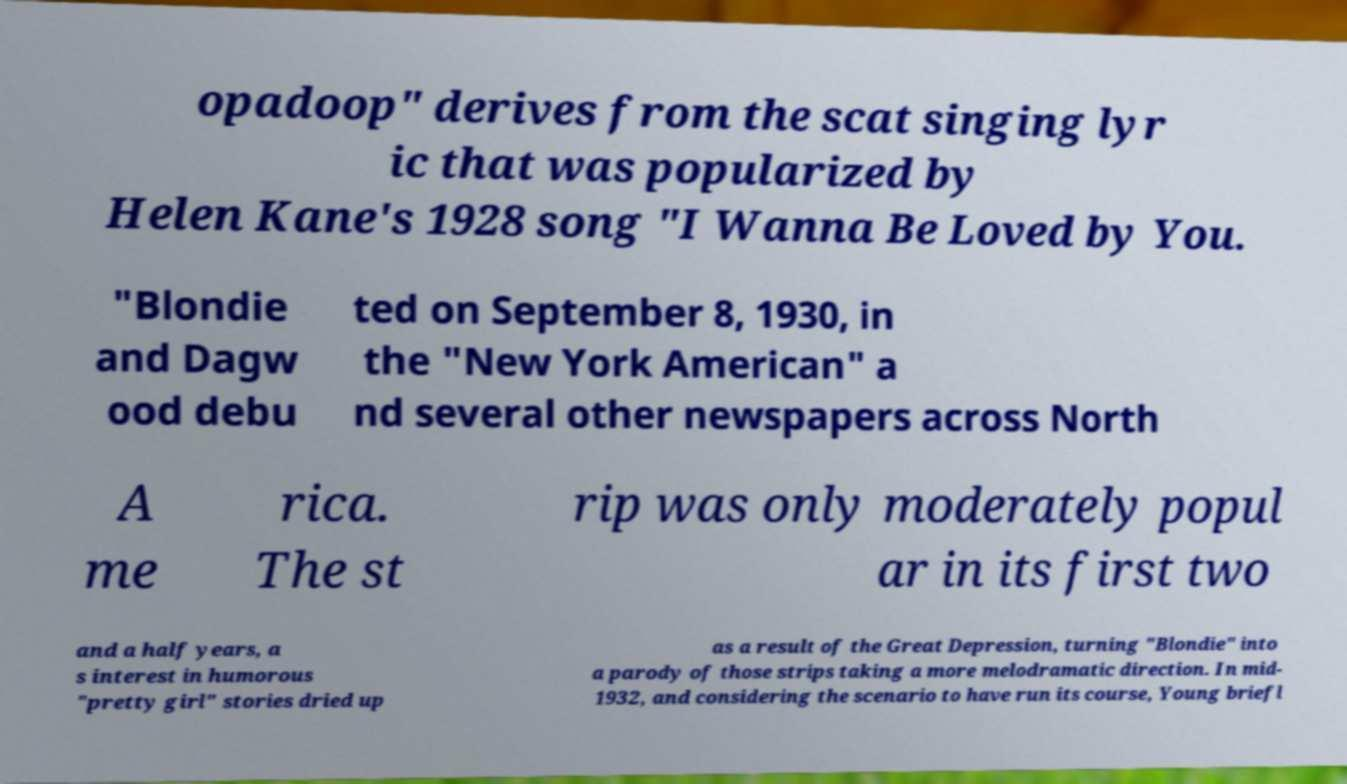Can you read and provide the text displayed in the image?This photo seems to have some interesting text. Can you extract and type it out for me? opadoop" derives from the scat singing lyr ic that was popularized by Helen Kane's 1928 song "I Wanna Be Loved by You. "Blondie and Dagw ood debu ted on September 8, 1930, in the "New York American" a nd several other newspapers across North A me rica. The st rip was only moderately popul ar in its first two and a half years, a s interest in humorous "pretty girl" stories dried up as a result of the Great Depression, turning "Blondie" into a parody of those strips taking a more melodramatic direction. In mid- 1932, and considering the scenario to have run its course, Young briefl 